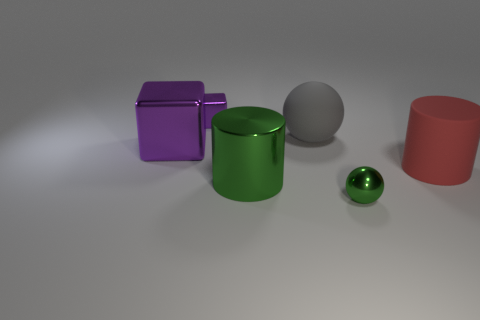Add 2 red rubber cylinders. How many objects exist? 8 Add 1 gray rubber balls. How many gray rubber balls are left? 2 Add 4 tiny blocks. How many tiny blocks exist? 5 Subtract 0 purple spheres. How many objects are left? 6 Subtract all cylinders. How many objects are left? 4 Subtract all big gray objects. Subtract all small metallic cubes. How many objects are left? 4 